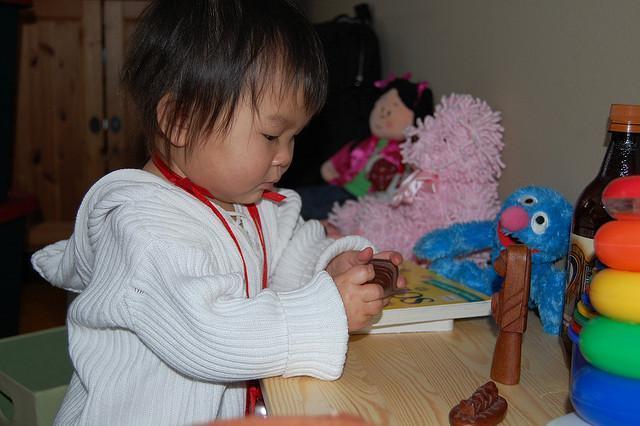How many dolls are in the image?
Give a very brief answer. 3. How many dolls are there?
Give a very brief answer. 1. How many stuffed animals are in the bin?
Give a very brief answer. 3. How many children are visible in this photo?
Give a very brief answer. 1. 